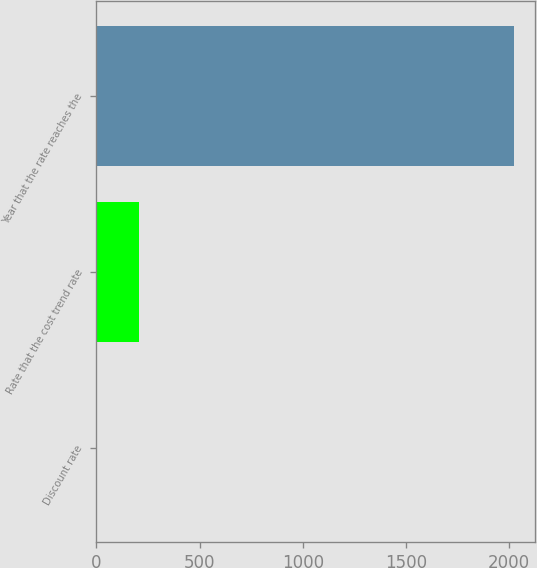Convert chart to OTSL. <chart><loc_0><loc_0><loc_500><loc_500><bar_chart><fcel>Discount rate<fcel>Rate that the cost trend rate<fcel>Year that the rate reaches the<nl><fcel>3.5<fcel>205.35<fcel>2022<nl></chart> 